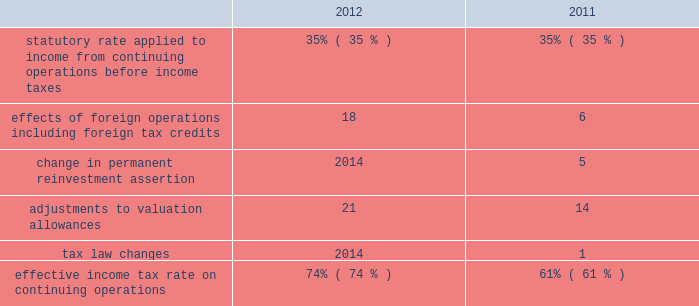Provision for income taxes increased $ 1791 million in 2012 from 2011 primarily due to the increase in pretax income from continuing operations , including the impact of the resumption of sales in libya in the first quarter of 2012 .
The following is an analysis of the effective income tax rates for 2012 and 2011: .
The effective income tax rate is influenced by a variety of factors including the geographic sources of income and the relative magnitude of these sources of income .
The provision for income taxes is allocated on a discrete , stand-alone basis to pretax segment income and to individual items not allocated to segments .
The difference between the total provision and the sum of the amounts allocated to segments appears in the "corporate and other unallocated items" shown in the reconciliation of segment income to net income below .
Effects of foreign operations 2013 the effects of foreign operations on our effective tax rate increased in 2012 as compared to 2011 , primarily due to the resumption of sales in libya in the first quarter of 2012 , where the statutory rate is in excess of 90 percent .
Change in permanent reinvestment assertion 2013 in the second quarter of 2011 , we recorded $ 716 million of deferred u.s .
Tax on undistributed earnings of $ 2046 million that we previously intended to permanently reinvest in foreign operations .
Offsetting this tax expense were associated foreign tax credits of $ 488 million .
In addition , we reduced our valuation allowance related to foreign tax credits by $ 228 million due to recognizing deferred u.s .
Tax on previously undistributed earnings .
Adjustments to valuation allowances 2013 in 2012 and 2011 , we increased the valuation allowance against foreign tax credits because it is more likely than not that we will be unable to realize all u.s .
Benefits on foreign taxes accrued in those years .
See item 8 .
Financial statements and supplementary data - note 10 to the consolidated financial statements for further information about income taxes .
Discontinued operations is presented net of tax , and reflects our downstream business that was spun off june 30 , 2011 and our angola business which we agreed to sell in 2013 .
See item 8 .
Financial statements and supplementary data 2013 notes 3 and 6 to the consolidated financial statements for additional information. .
What was the average effective income tax rate on continuing operations? 
Computations: ((74 + 61) / 2)
Answer: 67.5. 